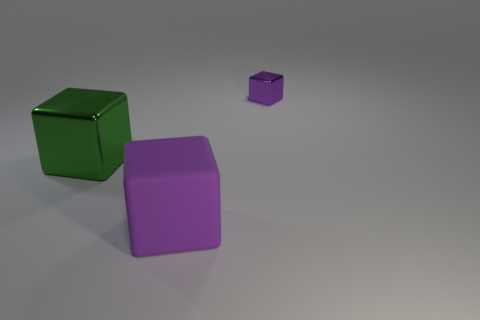Does the large rubber object that is left of the tiny metallic thing have the same color as the tiny cube?
Make the answer very short. Yes. How many small metallic things are the same shape as the big purple rubber thing?
Provide a succinct answer. 1. There is a purple object that is the same material as the big green block; what is its size?
Offer a very short reply. Small. There is a object that is behind the metal cube left of the tiny metal cube; is there a object that is in front of it?
Make the answer very short. Yes. There is a purple block in front of the green metal thing; is its size the same as the green metal object?
Your answer should be very brief. Yes. What number of green shiny spheres have the same size as the purple rubber thing?
Make the answer very short. 0. The other matte block that is the same color as the small cube is what size?
Make the answer very short. Large. Does the matte cube have the same color as the small metallic object?
Give a very brief answer. Yes. What is the shape of the large green shiny object?
Your answer should be very brief. Cube. Are there any other small things that have the same color as the matte thing?
Your answer should be very brief. Yes. 